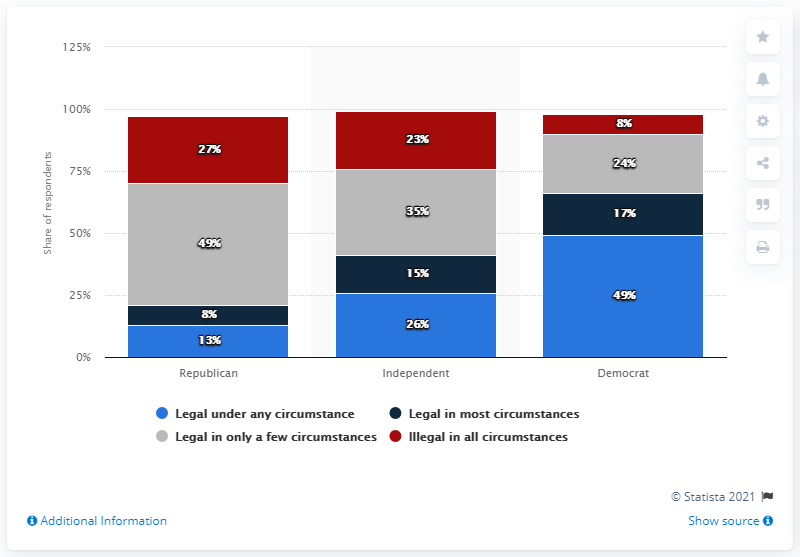How do the views on abortion legality differ among Republicans, Independents, and Democrats according to this chart? The chart shows a significant difference in views on abortion legality among the three groups. A small fraction of Republicans (8%) believe abortion should be legal under any circumstance, and 13% think it should be legal in only a few circumstances. Among Independents, the support for legalization under any circumstance is relatively higher at 15%, with 26% supporting legalization in a few circumstances. Democrats show the most support, with 49% supporting legalization under any circumstance and 17% in just a few circumstances. 